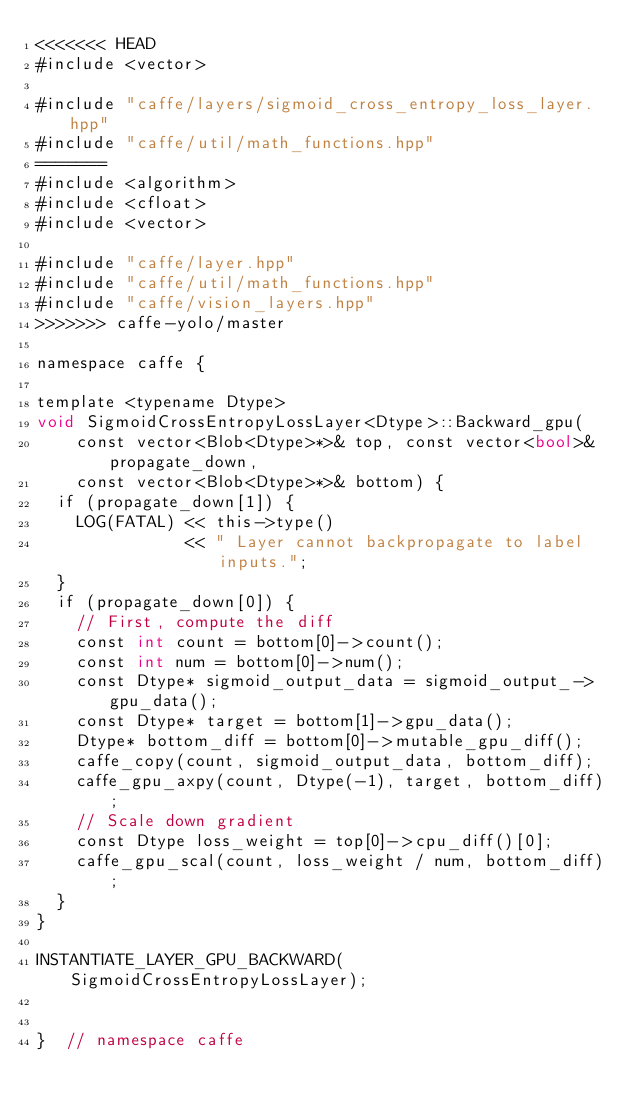<code> <loc_0><loc_0><loc_500><loc_500><_Cuda_><<<<<<< HEAD
#include <vector>

#include "caffe/layers/sigmoid_cross_entropy_loss_layer.hpp"
#include "caffe/util/math_functions.hpp"
=======
#include <algorithm>
#include <cfloat>
#include <vector>

#include "caffe/layer.hpp"
#include "caffe/util/math_functions.hpp"
#include "caffe/vision_layers.hpp"
>>>>>>> caffe-yolo/master

namespace caffe {

template <typename Dtype>
void SigmoidCrossEntropyLossLayer<Dtype>::Backward_gpu(
    const vector<Blob<Dtype>*>& top, const vector<bool>& propagate_down,
    const vector<Blob<Dtype>*>& bottom) {
  if (propagate_down[1]) {
    LOG(FATAL) << this->type()
               << " Layer cannot backpropagate to label inputs.";
  }
  if (propagate_down[0]) {
    // First, compute the diff
    const int count = bottom[0]->count();
    const int num = bottom[0]->num();
    const Dtype* sigmoid_output_data = sigmoid_output_->gpu_data();
    const Dtype* target = bottom[1]->gpu_data();
    Dtype* bottom_diff = bottom[0]->mutable_gpu_diff();
    caffe_copy(count, sigmoid_output_data, bottom_diff);
    caffe_gpu_axpy(count, Dtype(-1), target, bottom_diff);
    // Scale down gradient
    const Dtype loss_weight = top[0]->cpu_diff()[0];
    caffe_gpu_scal(count, loss_weight / num, bottom_diff);
  }
}

INSTANTIATE_LAYER_GPU_BACKWARD(SigmoidCrossEntropyLossLayer);


}  // namespace caffe
</code> 